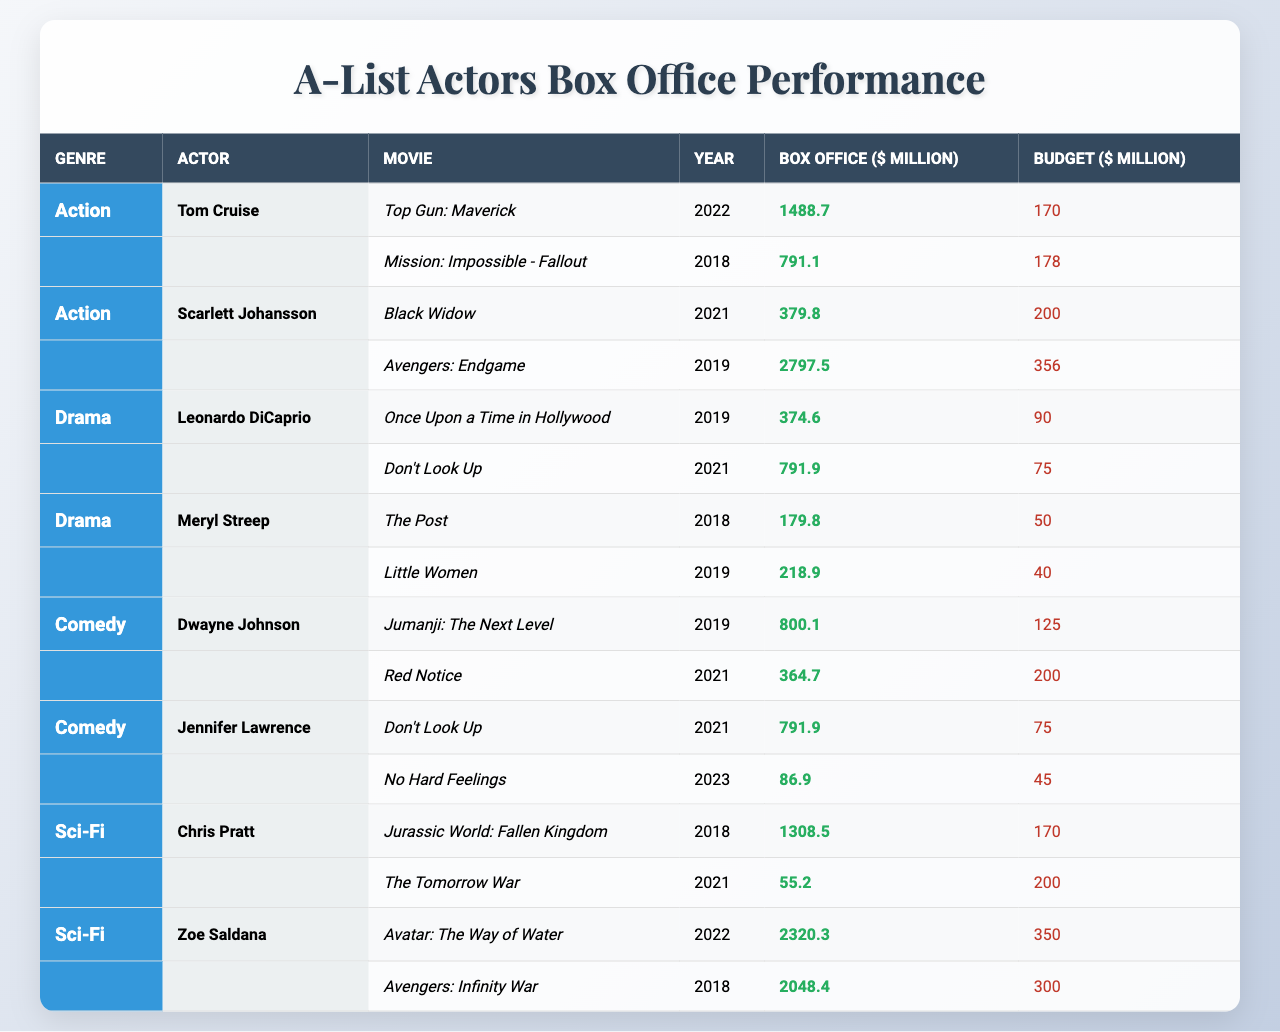What is the highest box office performance for Tom Cruise? According to the table, Tom Cruise's highest box office performance is from "Top Gun: Maverick" with a box office of 1488.7 million.
Answer: 1488.7 million Which movie earned the most for Scarlett Johansson? The table shows that Scarlett Johansson's movie with the highest box office earnings is "Avengers: Endgame," which made 2797.5 million.
Answer: 2797.5 million What is the total box office performance of all movies by Leonardo DiCaprio listed in the table? Leonardo DiCaprio has two movies: "Once Upon a Time in Hollywood" with 374.6 million and "Don't Look Up" with 791.9 million. Adding these gives a total of 374.6 + 791.9 = 1166.5 million.
Answer: 1166.5 million True or False: Meryl Streep's "Little Women" had a budget higher than its box office earnings. The box office for "Little Women" is 218.9 million, while the budget was 40 million, which means the box office was higher. Therefore, the statement is false.
Answer: False Which genre did Dwayne Johnson perform best in based on the box office earnings of his movies? Dwayne Johnson has two movies: "Jumanji: The Next Level" with 800.1 million and "Red Notice" with 364.7 million. The better performing movie, 800.1 million, is in the comedy genre.
Answer: Comedy What is the average box office performance of Chris Pratt's movies? Chris Pratt has two movies: "Jurassic World: Fallen Kingdom" (1308.5 million) and "The Tomorrow War" (55.2 million). First, sum the box offices: 1308.5 + 55.2 = 1363.7 million. There are two movies, so the average is 1363.7 / 2 = 681.85 million.
Answer: 681.85 million Which actor appears in a movie that has a box office over 2000 million? The table shows Zoe Saldana's "Avatar: The Way of Water" with a box office of 2320.3 million, which exceeds 2000 million.
Answer: Zoe Saldana What is the total budget of all movies listed for Jennifer Lawrence? Jennifer Lawrence's movies are "Don't Look Up" with a budget of 75 million and "No Hard Feelings" with a budget of 45 million. Adding these budgets gives: 75 + 45 = 120 million.
Answer: 120 million Which actor has the highest combined box office performance from their listed movies? To find this, calculate the total box office for each actor. For example, Scarlett Johansson (379.8 + 2797.5 = 3177.3 million), while Tom Cruise (1488.7 + 791.1 = 2279.8 million). Scarlett Johansson holds the highest at 3177.3 million.
Answer: Scarlett Johansson What genre had the highest box office performance for a single movie? The highest box office performance from the table is "Avengers: Endgame" by Scarlett Johansson at 2797.5 million. Thus, the genre is action.
Answer: Action 